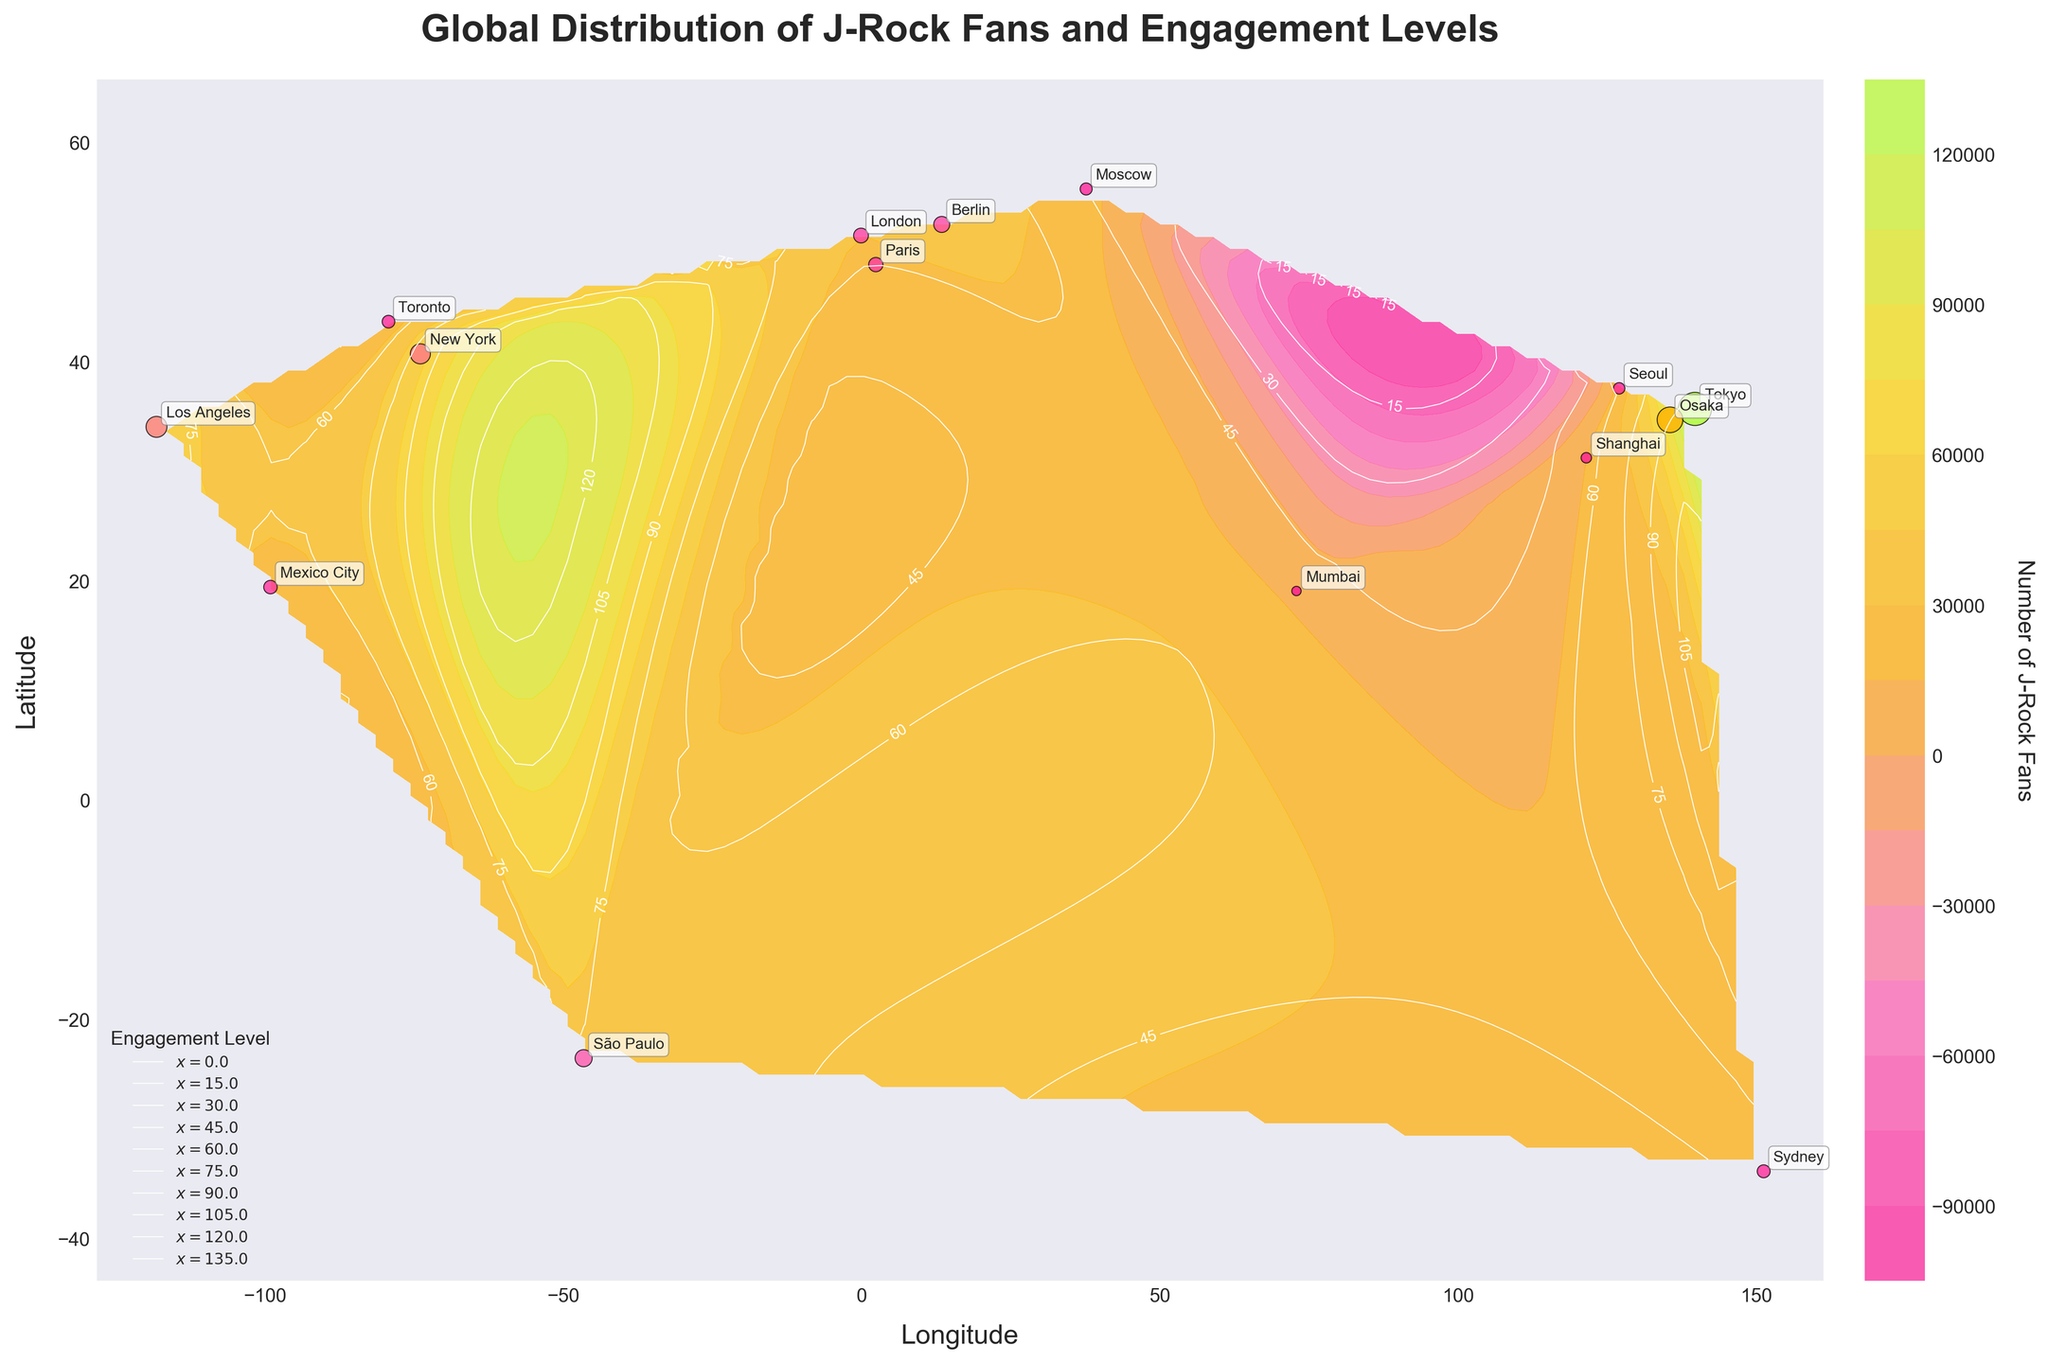what is the title of the plot? The title of the plot is displayed prominently at the top and describes the content of the visualization. The title reads 'Global Distribution of J-Rock Fans and Engagement Levels.'
Answer: Global Distribution of J-Rock Fans and Engagement Levels What colors predominantly appear in the contour plot? The contour plot uses a custom color scheme that mainly features shades of pinks, oranges, and greens. These colors are used to represent the number of J-Rock fans.
Answer: Pinks, oranges, and greens How many cities are annotated on the plot? The cities are marked with text annotations using the data provided. By counting the labels, we can determine there are 14 cities indicated on the plot.
Answer: 14 Which city has the highest number of J-Rock fans? From the annotations and visual representation of scatter points, Tokyo is represented by the largest dot and is clearly marked as having 150,000 J-Rock fans, the highest number.
Answer: Tokyo What is the engagement level contour value for New York? The engagement levels are shown using contour lines, with specific values labeled. By identifying New York's position and referring to the contour lines, we can see that New York's engagement level is 80.
Answer: 80 Which continent has the highest concentration of J-Rock fans? The large scatter points clustered in Japan indicate a high number of J-Rock fans in Asia, specifically in Tokyo and Osaka. Thus, Asia has the highest concentration of fans.
Answer: Asia How does São Paulo's J-Rock fan engagement level compare to Berlin's? Observing the contour lines, São Paulo is marked with an engagement level of 75, while Berlin shows an engagement level of 70, indicating São Paulo has a higher engagement level.
Answer: São Paulo has a higher engagement level than Berlin What is the geographical location with the lowest engagement level? By examining the contour plot, we identify the lowest labeled contour value. Moscow is marked with an engagement level of 45, the lowest among the annotated cities.
Answer: Moscow What can be said about the relationship between the number of J-Rock fans and the engagement level in Tokyo and Los Angeles? The large dot size and contour labels show Tokyo has 150,000 fans with an engagement level of 95, while a smaller dot for Los Angeles shows 60,000 fans with an engagement level of 85. Generally, higher fans correlate with higher engagement.
Answer: Higher number of fans corresponds to higher engagement in both Tokyo and Los Angeles Which two cities are closest in terms of engagement levels? Analyzing the engagement level contours, we find that Sydney and Mumbai both have an engagement level of 50, making them the closest in this metric.
Answer: Sydney and Mumbai 